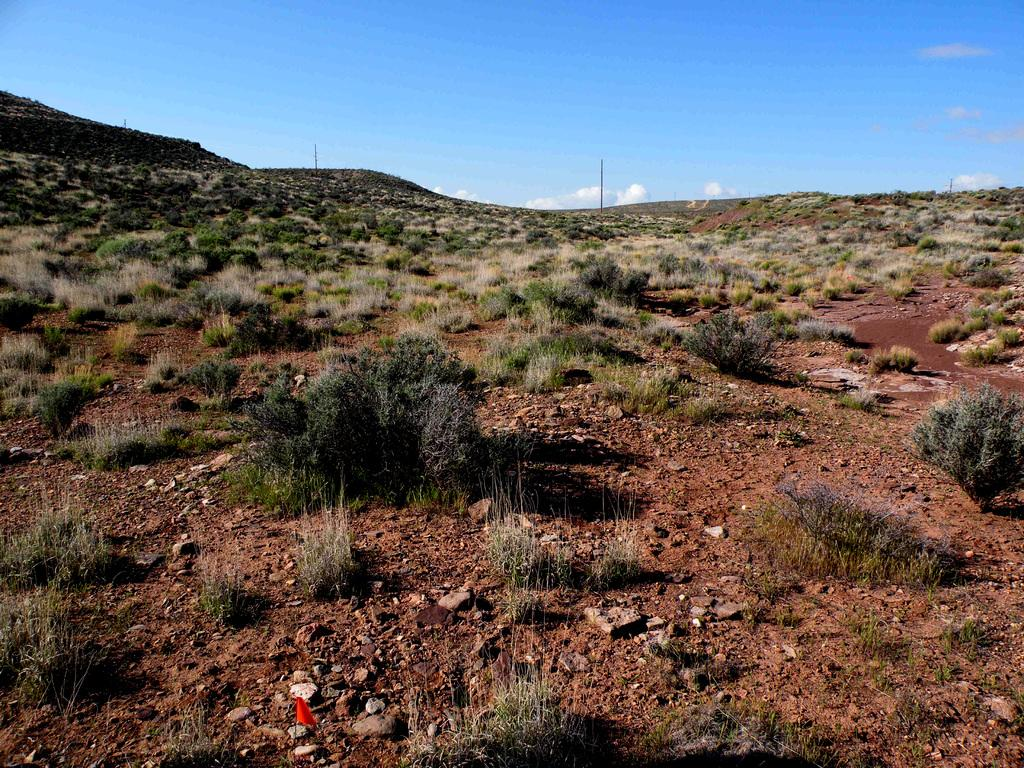What geographical feature is present in the image? There is a hill in the image. What can be found on the hill? There is a group of plants and poles on the hill. What is visible at the top of the image? The sky is clear at the top of the image. Where is the oven located in the image? There is no oven present in the image. What type of yam is growing on the hill in the image? There are no yams present in the image; only a group of plants is visible. 